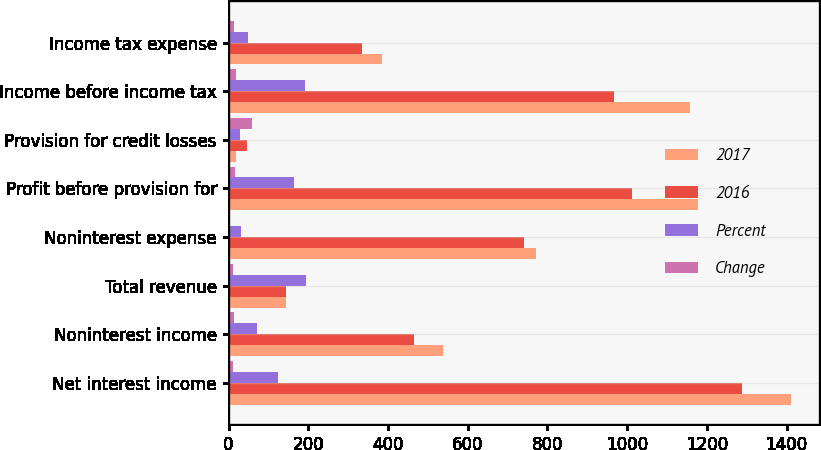Convert chart. <chart><loc_0><loc_0><loc_500><loc_500><stacked_bar_chart><ecel><fcel>Net interest income<fcel>Noninterest income<fcel>Total revenue<fcel>Noninterest expense<fcel>Profit before provision for<fcel>Provision for credit losses<fcel>Income before income tax<fcel>Income tax expense<nl><fcel>2017<fcel>1411<fcel>538<fcel>143.5<fcel>772<fcel>1177<fcel>19<fcel>1158<fcel>384<nl><fcel>2016<fcel>1288<fcel>466<fcel>143.5<fcel>741<fcel>1013<fcel>47<fcel>966<fcel>335<nl><fcel>Percent<fcel>123<fcel>72<fcel>195<fcel>31<fcel>164<fcel>28<fcel>192<fcel>49<nl><fcel>Change<fcel>10<fcel>15<fcel>11<fcel>4<fcel>16<fcel>60<fcel>20<fcel>15<nl></chart> 